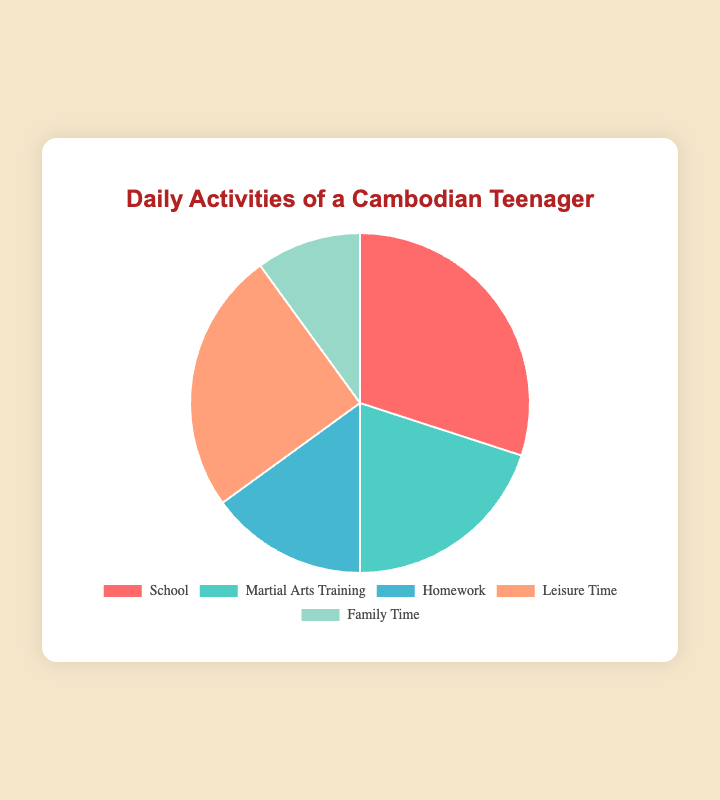1. Which activity takes up the most time? The largest segment of the pie chart represents the activity with the highest percentage. School occupies 30%, which is the largest portion.
Answer: School 2. How much more time is spent on Leisure Time compared to Family Time? Directly compare the percentages for Leisure Time (25%) and Family Time (10%), then calculate the difference: 25% - 10% = 15%.
Answer: 15% 3. What is the total percentage of time spent on Martial Arts Training and Homework combined? Sum the percentages for Martial Arts Training (20%) and Homework (15%): 20% + 15% = 35%.
Answer: 35% 4. Which activity takes up the least amount of time? The smallest segment of the pie chart represents the activity with the lowest percentage. Family Time occupies 10%, which is the smallest portion.
Answer: Family Time 5. How much time is not spent on School? Subtract the percentage of time spent on School (30%) from the total 100%: 100% - 30% = 70%.
Answer: 70% 6. Compare the time spent on School and Martial Arts Training. Which one is greater? School accounts for 30% while Martial Arts Training accounts for 20%. Therefore, more time is spent on School.
Answer: School 7. What is the average percentage of time spent on all activities? Sum all the percentages for each activity and then divide by the number of activities. (30% + 20% + 15% + 25% + 10%) / 5 = 100% / 5 = 20%.
Answer: 20% 8. If time allocated to Family Time is increased by 5%, what will be the new percentage? Add 5% to the current Family Time percentage: 10% + 5% = 15%.
Answer: 15% 9. What fraction of the total daily activities is devoted to Homework? Homework takes up 15% of the total, so the fraction is 15/100, which simplifies to 3/20.
Answer: 3/20 10. Which activities combined take up more than half of the total time? Sum the percentages of different combinations to see if they exceed 50%. The combination of School (30%) and Leisure Time (25%) equals 55%, which is more than half.
Answer: School and Leisure Time 